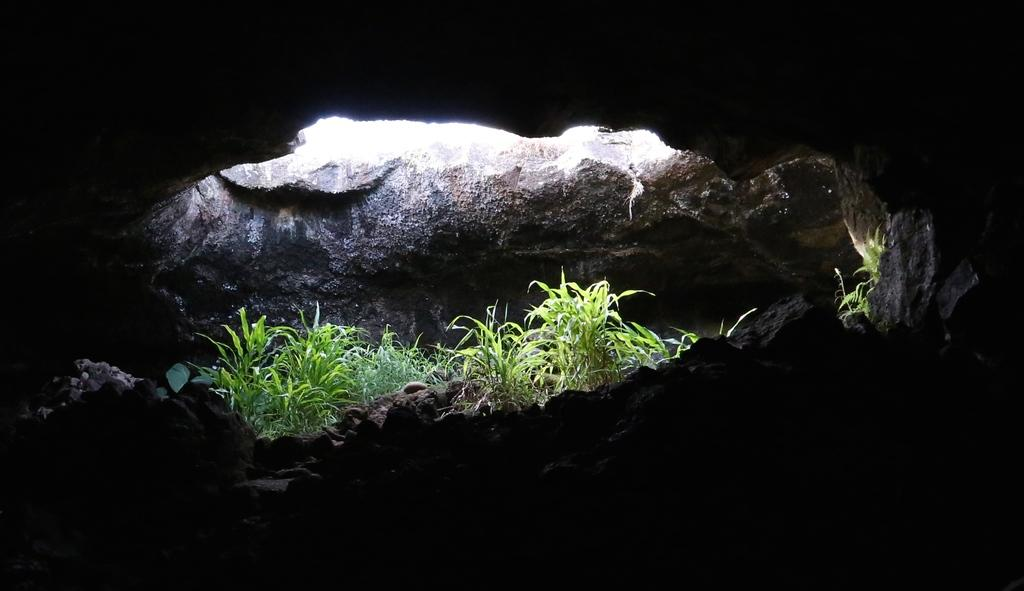What type of location is depicted in the image? The image is an inside view of a cave. What can be seen on the ground or walls of the cave? There are rocks in the image. Are there any living organisms visible in the cave? Yes, there are plants in the image. Can you tell me where the key is located in the image? There is no key present in the image. What type of sticks are being used by the porter in the image? There is no porter or sticks present in the image. 